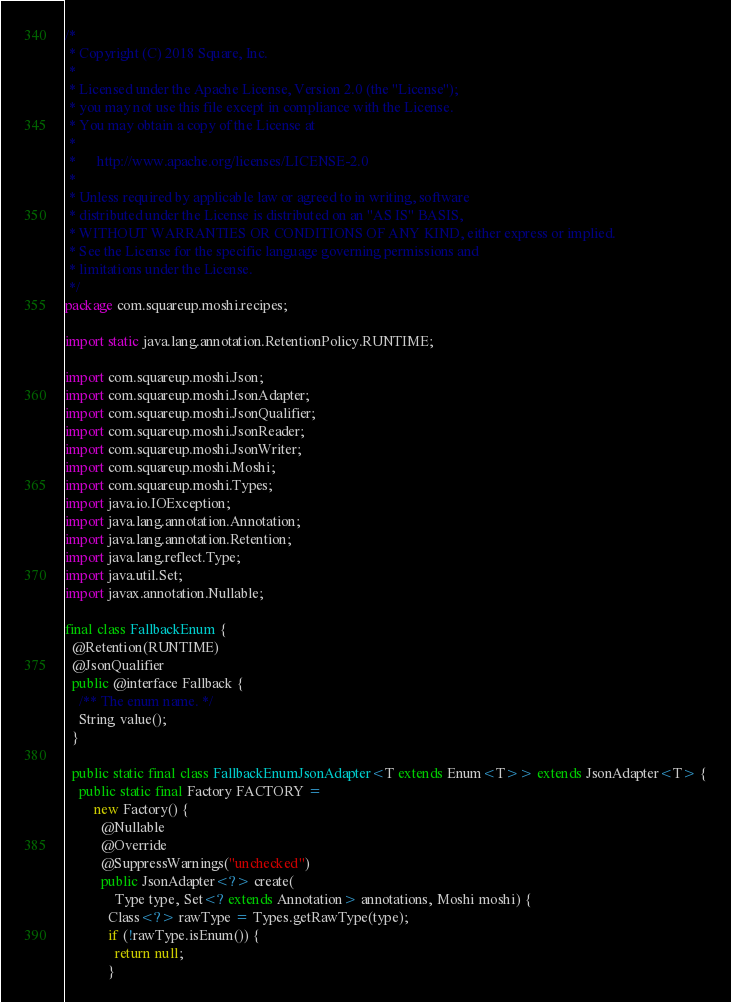<code> <loc_0><loc_0><loc_500><loc_500><_Java_>/*
 * Copyright (C) 2018 Square, Inc.
 *
 * Licensed under the Apache License, Version 2.0 (the "License");
 * you may not use this file except in compliance with the License.
 * You may obtain a copy of the License at
 *
 *      http://www.apache.org/licenses/LICENSE-2.0
 *
 * Unless required by applicable law or agreed to in writing, software
 * distributed under the License is distributed on an "AS IS" BASIS,
 * WITHOUT WARRANTIES OR CONDITIONS OF ANY KIND, either express or implied.
 * See the License for the specific language governing permissions and
 * limitations under the License.
 */
package com.squareup.moshi.recipes;

import static java.lang.annotation.RetentionPolicy.RUNTIME;

import com.squareup.moshi.Json;
import com.squareup.moshi.JsonAdapter;
import com.squareup.moshi.JsonQualifier;
import com.squareup.moshi.JsonReader;
import com.squareup.moshi.JsonWriter;
import com.squareup.moshi.Moshi;
import com.squareup.moshi.Types;
import java.io.IOException;
import java.lang.annotation.Annotation;
import java.lang.annotation.Retention;
import java.lang.reflect.Type;
import java.util.Set;
import javax.annotation.Nullable;

final class FallbackEnum {
  @Retention(RUNTIME)
  @JsonQualifier
  public @interface Fallback {
    /** The enum name. */
    String value();
  }

  public static final class FallbackEnumJsonAdapter<T extends Enum<T>> extends JsonAdapter<T> {
    public static final Factory FACTORY =
        new Factory() {
          @Nullable
          @Override
          @SuppressWarnings("unchecked")
          public JsonAdapter<?> create(
              Type type, Set<? extends Annotation> annotations, Moshi moshi) {
            Class<?> rawType = Types.getRawType(type);
            if (!rawType.isEnum()) {
              return null;
            }</code> 